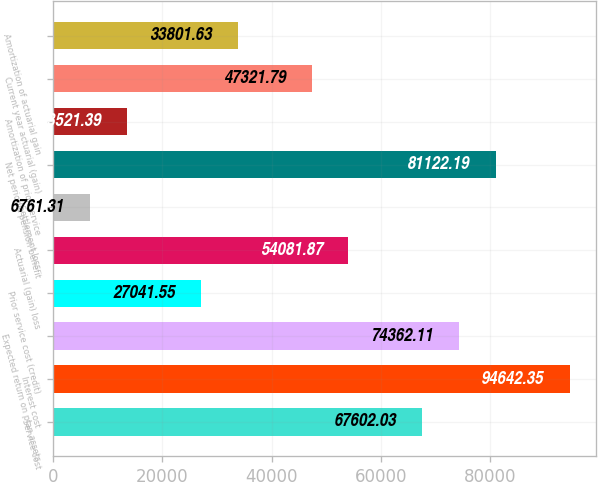<chart> <loc_0><loc_0><loc_500><loc_500><bar_chart><fcel>Service cost<fcel>Interest cost<fcel>Expected return on plan assets<fcel>Prior service cost (credit)<fcel>Actuarial (gain) loss<fcel>Settlement loss<fcel>Net periodic pension benefit<fcel>Amortization of prior service<fcel>Current year actuarial (gain)<fcel>Amortization of actuarial gain<nl><fcel>67602<fcel>94642.4<fcel>74362.1<fcel>27041.5<fcel>54081.9<fcel>6761.31<fcel>81122.2<fcel>13521.4<fcel>47321.8<fcel>33801.6<nl></chart> 